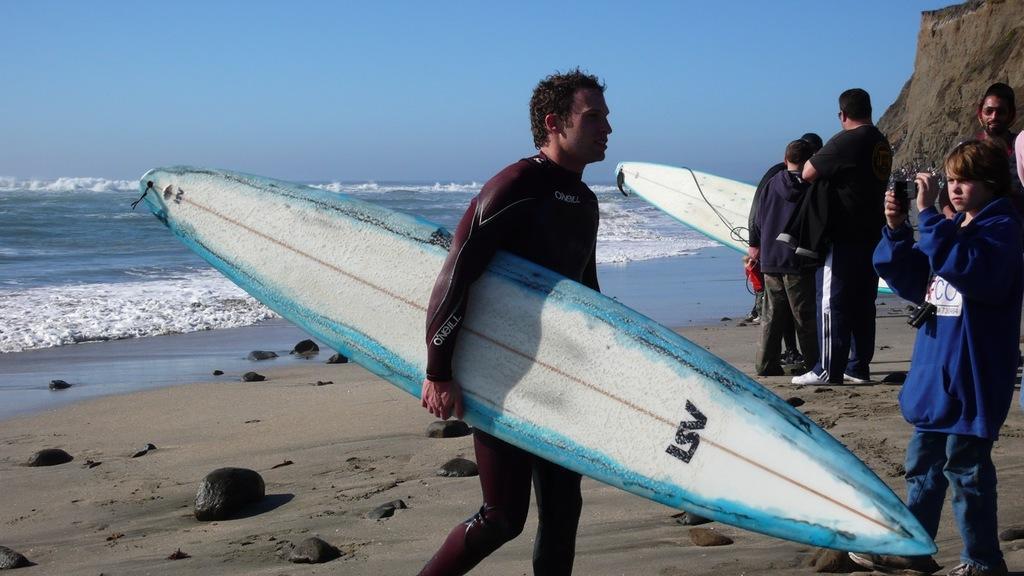Describe this image in one or two sentences. In this image I can see the sand, few stones, few persons, few of them are holding surfboards and a person is holding a camera. In the background I can see the water, a mountain and the sky. 